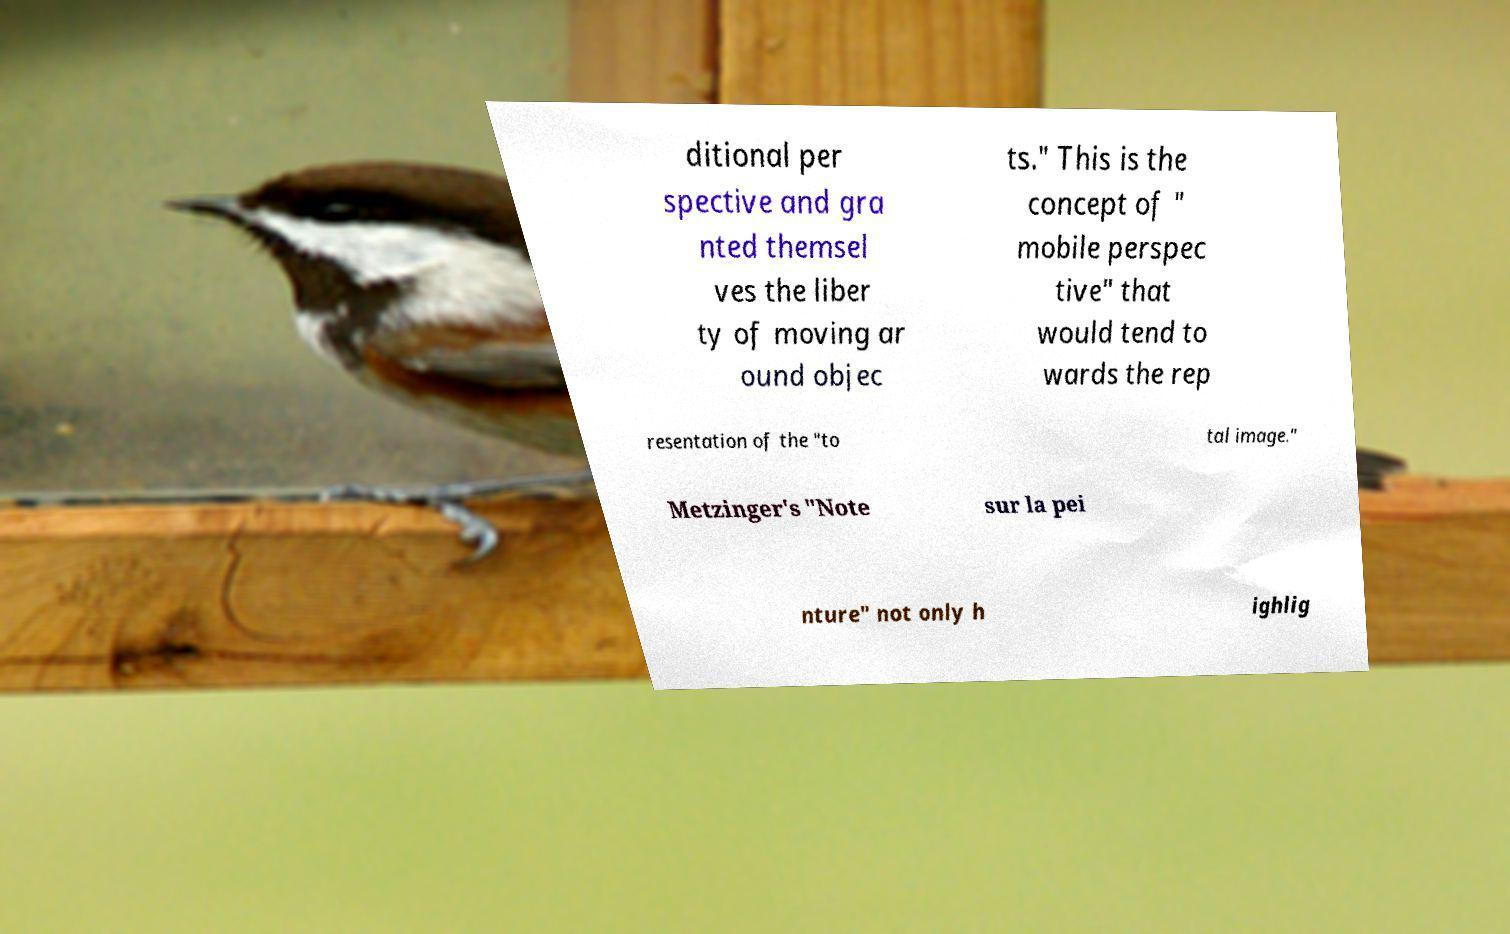Could you assist in decoding the text presented in this image and type it out clearly? ditional per spective and gra nted themsel ves the liber ty of moving ar ound objec ts." This is the concept of " mobile perspec tive" that would tend to wards the rep resentation of the "to tal image." Metzinger's "Note sur la pei nture" not only h ighlig 